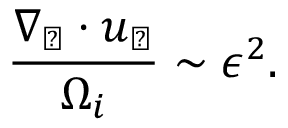Convert formula to latex. <formula><loc_0><loc_0><loc_500><loc_500>\frac { \nabla _ { \perp } \cdot u _ { \perp } } { \Omega _ { i } } \sim \epsilon ^ { 2 } .</formula> 